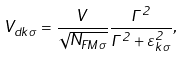Convert formula to latex. <formula><loc_0><loc_0><loc_500><loc_500>V _ { d k \sigma } = \frac { V } { \sqrt { N _ { F M \sigma } } } \frac { \Gamma ^ { 2 } } { \Gamma ^ { 2 } + \varepsilon _ { k \sigma } ^ { 2 } } ,</formula> 